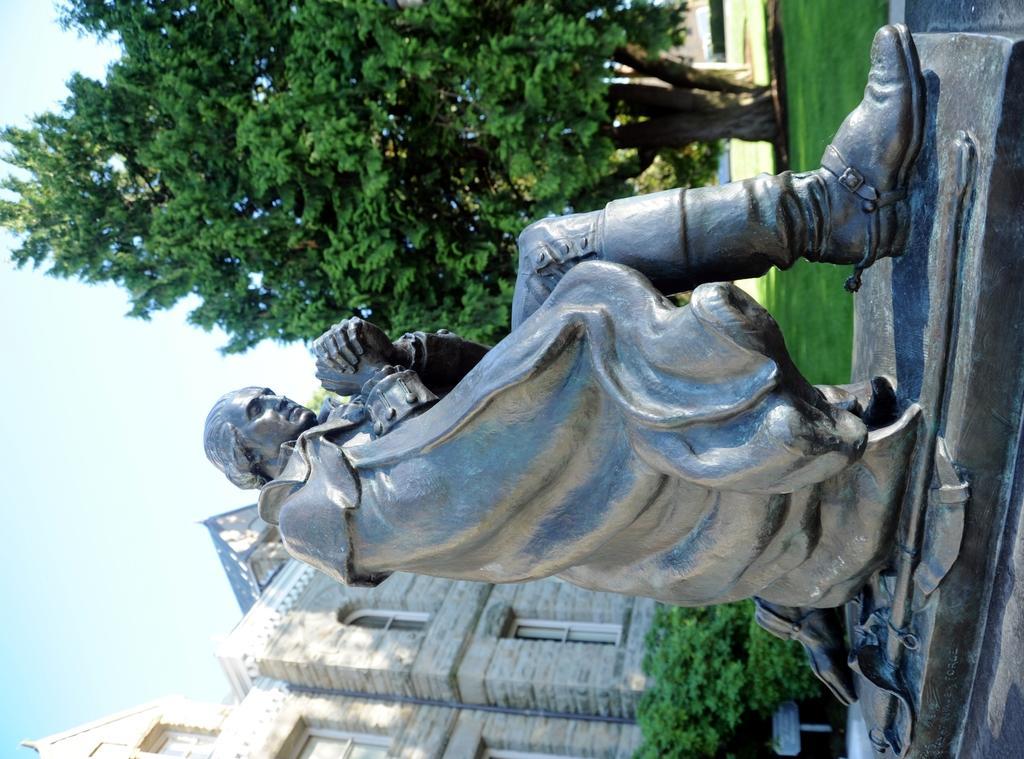Can you describe this image briefly? This is the statue of the man. These are the bushes. This is the building with windows. I can see the tree with branches and leaves. Here is the grass. 